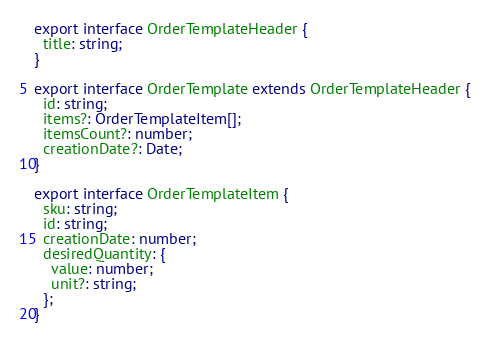<code> <loc_0><loc_0><loc_500><loc_500><_TypeScript_>export interface OrderTemplateHeader {
  title: string;
}

export interface OrderTemplate extends OrderTemplateHeader {
  id: string;
  items?: OrderTemplateItem[];
  itemsCount?: number;
  creationDate?: Date;
}

export interface OrderTemplateItem {
  sku: string;
  id: string;
  creationDate: number;
  desiredQuantity: {
    value: number;
    unit?: string;
  };
}
</code> 